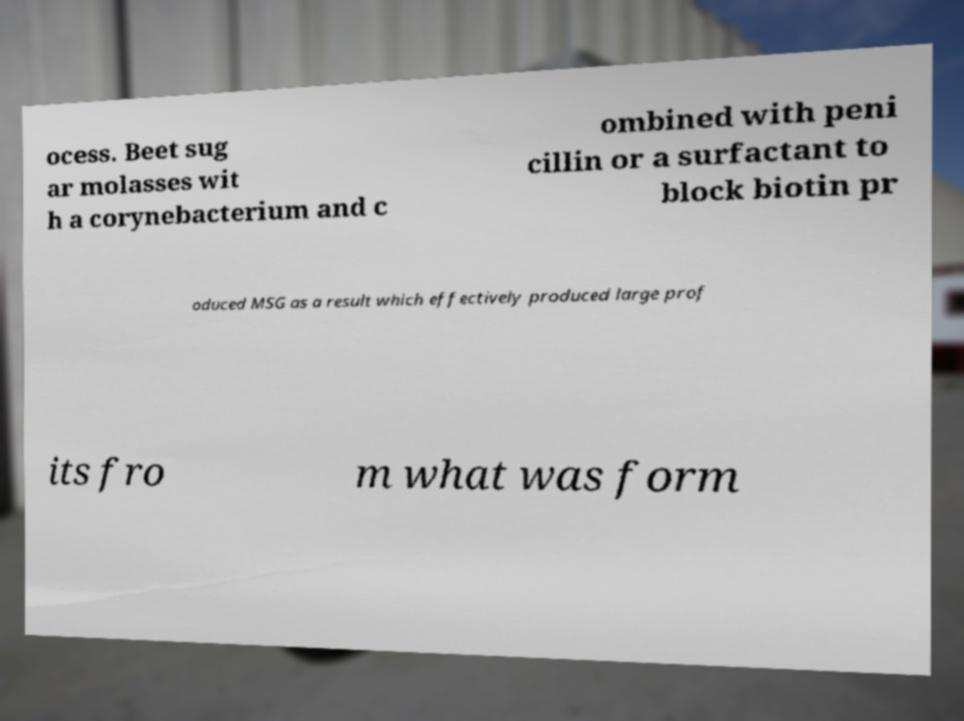Please read and relay the text visible in this image. What does it say? ocess. Beet sug ar molasses wit h a corynebacterium and c ombined with peni cillin or a surfactant to block biotin pr oduced MSG as a result which effectively produced large prof its fro m what was form 